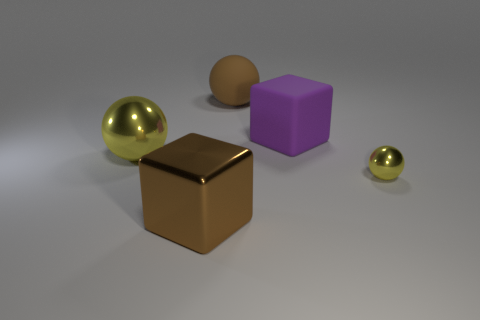Do the big cube that is behind the big yellow metallic object and the matte sphere have the same color?
Make the answer very short. No. What number of big objects are in front of the large yellow ball and on the right side of the large brown matte thing?
Offer a very short reply. 0. How many other things are the same material as the brown ball?
Keep it short and to the point. 1. Do the large cube that is behind the brown shiny object and the large brown ball have the same material?
Offer a very short reply. Yes. There is a yellow thing that is to the left of the cube on the left side of the big object behind the purple rubber cube; what is its size?
Provide a succinct answer. Large. What number of other objects are there of the same color as the tiny metallic sphere?
Your response must be concise. 1. What is the shape of the purple matte object that is the same size as the brown shiny block?
Give a very brief answer. Cube. What is the size of the yellow sphere that is to the right of the big yellow metal sphere?
Give a very brief answer. Small. There is a large sphere that is in front of the purple rubber block; is it the same color as the large object that is in front of the small metallic thing?
Offer a very short reply. No. What material is the yellow sphere that is to the left of the yellow metallic ball that is right of the large brown thing that is behind the tiny yellow metal object made of?
Your answer should be very brief. Metal. 